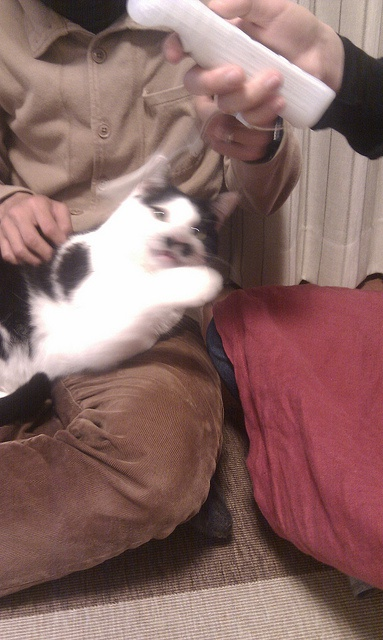Describe the objects in this image and their specific colors. I can see people in gray, brown, and maroon tones, cat in gray, white, black, and darkgray tones, people in gray, black, lightpink, and darkgray tones, and remote in gray, lightgray, and darkgray tones in this image. 